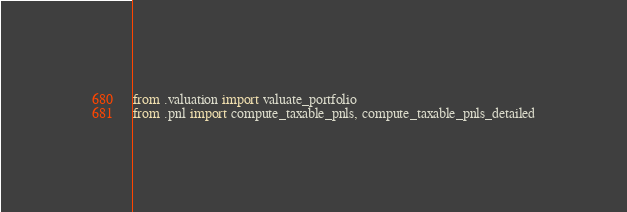<code> <loc_0><loc_0><loc_500><loc_500><_Python_>
from .valuation import valuate_portfolio
from .pnl import compute_taxable_pnls, compute_taxable_pnls_detailed
</code> 